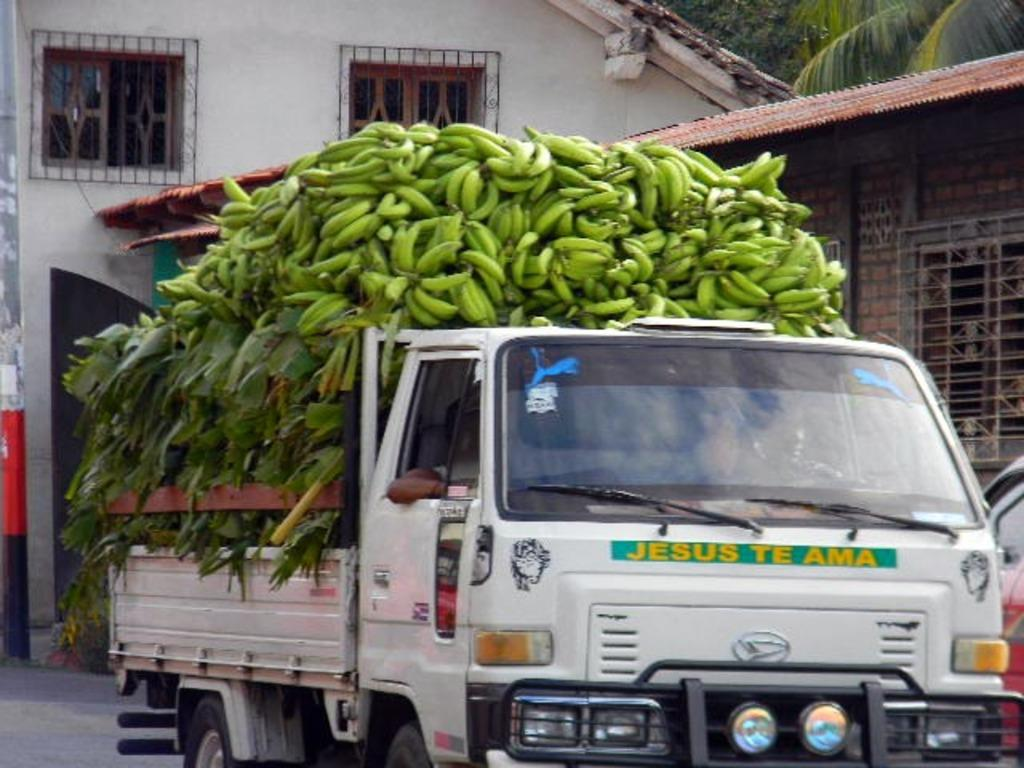What is the main subject of the image? The main subject of the image is a truck. What is the truck carrying? The truck is carrying bananas. What can be seen in the background of the image? There is a house and trees in the background of the image. What is visible at the bottom of the image? There is a road visible at the bottom of the image. Where is the nearest hospital to the truck in the image? There is no information about the location of a hospital in the image, so it cannot be determined. 